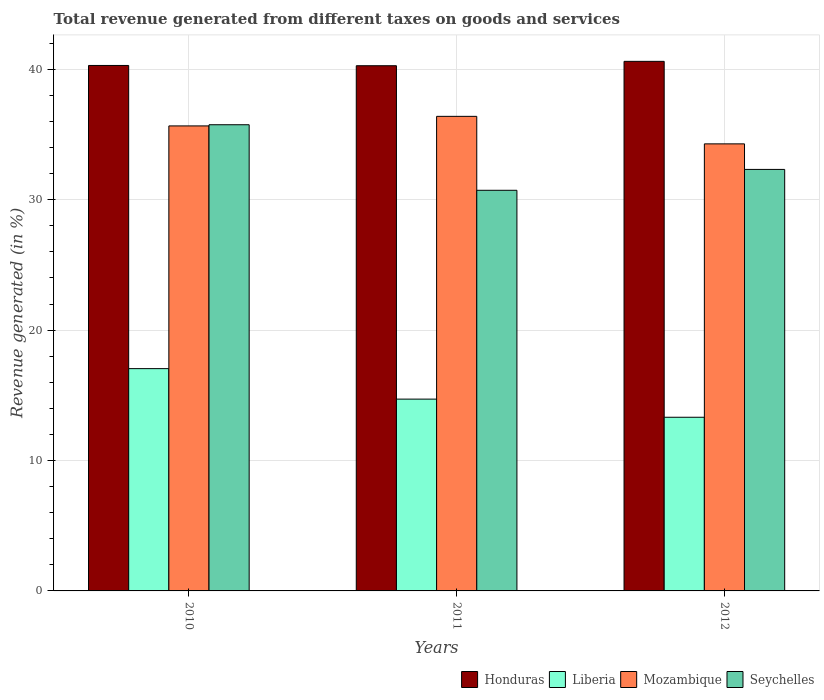How many groups of bars are there?
Your answer should be compact. 3. What is the label of the 3rd group of bars from the left?
Give a very brief answer. 2012. In how many cases, is the number of bars for a given year not equal to the number of legend labels?
Provide a short and direct response. 0. What is the total revenue generated in Mozambique in 2010?
Ensure brevity in your answer.  35.66. Across all years, what is the maximum total revenue generated in Mozambique?
Offer a very short reply. 36.39. Across all years, what is the minimum total revenue generated in Liberia?
Make the answer very short. 13.32. In which year was the total revenue generated in Seychelles minimum?
Your answer should be very brief. 2011. What is the total total revenue generated in Seychelles in the graph?
Provide a succinct answer. 98.79. What is the difference between the total revenue generated in Seychelles in 2010 and that in 2011?
Your answer should be very brief. 5.03. What is the difference between the total revenue generated in Honduras in 2010 and the total revenue generated in Liberia in 2012?
Your answer should be very brief. 26.98. What is the average total revenue generated in Honduras per year?
Provide a succinct answer. 40.39. In the year 2010, what is the difference between the total revenue generated in Honduras and total revenue generated in Mozambique?
Give a very brief answer. 4.64. What is the ratio of the total revenue generated in Liberia in 2010 to that in 2012?
Offer a very short reply. 1.28. Is the total revenue generated in Liberia in 2010 less than that in 2011?
Your answer should be very brief. No. What is the difference between the highest and the second highest total revenue generated in Honduras?
Provide a short and direct response. 0.31. What is the difference between the highest and the lowest total revenue generated in Mozambique?
Provide a succinct answer. 2.11. Is it the case that in every year, the sum of the total revenue generated in Mozambique and total revenue generated in Seychelles is greater than the sum of total revenue generated in Liberia and total revenue generated in Honduras?
Offer a terse response. No. What does the 4th bar from the left in 2010 represents?
Your response must be concise. Seychelles. What does the 2nd bar from the right in 2011 represents?
Your response must be concise. Mozambique. How many bars are there?
Keep it short and to the point. 12. Are all the bars in the graph horizontal?
Provide a succinct answer. No. How many years are there in the graph?
Make the answer very short. 3. What is the difference between two consecutive major ticks on the Y-axis?
Offer a very short reply. 10. Does the graph contain any zero values?
Give a very brief answer. No. Does the graph contain grids?
Make the answer very short. Yes. Where does the legend appear in the graph?
Make the answer very short. Bottom right. How are the legend labels stacked?
Provide a short and direct response. Horizontal. What is the title of the graph?
Provide a succinct answer. Total revenue generated from different taxes on goods and services. Does "El Salvador" appear as one of the legend labels in the graph?
Your answer should be compact. No. What is the label or title of the Y-axis?
Provide a succinct answer. Revenue generated (in %). What is the Revenue generated (in %) of Honduras in 2010?
Give a very brief answer. 40.29. What is the Revenue generated (in %) in Liberia in 2010?
Your response must be concise. 17.05. What is the Revenue generated (in %) of Mozambique in 2010?
Your response must be concise. 35.66. What is the Revenue generated (in %) in Seychelles in 2010?
Your response must be concise. 35.75. What is the Revenue generated (in %) in Honduras in 2011?
Offer a terse response. 40.27. What is the Revenue generated (in %) in Liberia in 2011?
Provide a succinct answer. 14.71. What is the Revenue generated (in %) of Mozambique in 2011?
Give a very brief answer. 36.39. What is the Revenue generated (in %) in Seychelles in 2011?
Provide a short and direct response. 30.72. What is the Revenue generated (in %) of Honduras in 2012?
Make the answer very short. 40.61. What is the Revenue generated (in %) in Liberia in 2012?
Provide a succinct answer. 13.32. What is the Revenue generated (in %) in Mozambique in 2012?
Your response must be concise. 34.28. What is the Revenue generated (in %) in Seychelles in 2012?
Your response must be concise. 32.32. Across all years, what is the maximum Revenue generated (in %) of Honduras?
Your answer should be compact. 40.61. Across all years, what is the maximum Revenue generated (in %) in Liberia?
Your answer should be very brief. 17.05. Across all years, what is the maximum Revenue generated (in %) of Mozambique?
Your response must be concise. 36.39. Across all years, what is the maximum Revenue generated (in %) of Seychelles?
Keep it short and to the point. 35.75. Across all years, what is the minimum Revenue generated (in %) of Honduras?
Offer a terse response. 40.27. Across all years, what is the minimum Revenue generated (in %) of Liberia?
Provide a succinct answer. 13.32. Across all years, what is the minimum Revenue generated (in %) of Mozambique?
Give a very brief answer. 34.28. Across all years, what is the minimum Revenue generated (in %) of Seychelles?
Ensure brevity in your answer.  30.72. What is the total Revenue generated (in %) in Honduras in the graph?
Provide a succinct answer. 121.17. What is the total Revenue generated (in %) in Liberia in the graph?
Your answer should be compact. 45.07. What is the total Revenue generated (in %) of Mozambique in the graph?
Provide a short and direct response. 106.33. What is the total Revenue generated (in %) in Seychelles in the graph?
Your answer should be compact. 98.79. What is the difference between the Revenue generated (in %) of Honduras in 2010 and that in 2011?
Make the answer very short. 0.02. What is the difference between the Revenue generated (in %) of Liberia in 2010 and that in 2011?
Provide a succinct answer. 2.34. What is the difference between the Revenue generated (in %) in Mozambique in 2010 and that in 2011?
Offer a terse response. -0.73. What is the difference between the Revenue generated (in %) of Seychelles in 2010 and that in 2011?
Offer a very short reply. 5.03. What is the difference between the Revenue generated (in %) of Honduras in 2010 and that in 2012?
Provide a short and direct response. -0.31. What is the difference between the Revenue generated (in %) in Liberia in 2010 and that in 2012?
Offer a terse response. 3.73. What is the difference between the Revenue generated (in %) of Mozambique in 2010 and that in 2012?
Ensure brevity in your answer.  1.38. What is the difference between the Revenue generated (in %) in Seychelles in 2010 and that in 2012?
Your answer should be very brief. 3.43. What is the difference between the Revenue generated (in %) in Honduras in 2011 and that in 2012?
Make the answer very short. -0.34. What is the difference between the Revenue generated (in %) of Liberia in 2011 and that in 2012?
Your answer should be very brief. 1.39. What is the difference between the Revenue generated (in %) in Mozambique in 2011 and that in 2012?
Offer a terse response. 2.11. What is the difference between the Revenue generated (in %) of Seychelles in 2011 and that in 2012?
Ensure brevity in your answer.  -1.6. What is the difference between the Revenue generated (in %) of Honduras in 2010 and the Revenue generated (in %) of Liberia in 2011?
Provide a succinct answer. 25.59. What is the difference between the Revenue generated (in %) in Honduras in 2010 and the Revenue generated (in %) in Mozambique in 2011?
Your response must be concise. 3.9. What is the difference between the Revenue generated (in %) in Honduras in 2010 and the Revenue generated (in %) in Seychelles in 2011?
Your answer should be compact. 9.57. What is the difference between the Revenue generated (in %) of Liberia in 2010 and the Revenue generated (in %) of Mozambique in 2011?
Your answer should be very brief. -19.35. What is the difference between the Revenue generated (in %) of Liberia in 2010 and the Revenue generated (in %) of Seychelles in 2011?
Your response must be concise. -13.68. What is the difference between the Revenue generated (in %) of Mozambique in 2010 and the Revenue generated (in %) of Seychelles in 2011?
Your answer should be very brief. 4.94. What is the difference between the Revenue generated (in %) of Honduras in 2010 and the Revenue generated (in %) of Liberia in 2012?
Your answer should be compact. 26.98. What is the difference between the Revenue generated (in %) of Honduras in 2010 and the Revenue generated (in %) of Mozambique in 2012?
Provide a short and direct response. 6.01. What is the difference between the Revenue generated (in %) in Honduras in 2010 and the Revenue generated (in %) in Seychelles in 2012?
Your answer should be very brief. 7.97. What is the difference between the Revenue generated (in %) of Liberia in 2010 and the Revenue generated (in %) of Mozambique in 2012?
Provide a short and direct response. -17.24. What is the difference between the Revenue generated (in %) in Liberia in 2010 and the Revenue generated (in %) in Seychelles in 2012?
Ensure brevity in your answer.  -15.28. What is the difference between the Revenue generated (in %) of Mozambique in 2010 and the Revenue generated (in %) of Seychelles in 2012?
Offer a very short reply. 3.34. What is the difference between the Revenue generated (in %) in Honduras in 2011 and the Revenue generated (in %) in Liberia in 2012?
Your answer should be compact. 26.96. What is the difference between the Revenue generated (in %) of Honduras in 2011 and the Revenue generated (in %) of Mozambique in 2012?
Offer a very short reply. 5.99. What is the difference between the Revenue generated (in %) of Honduras in 2011 and the Revenue generated (in %) of Seychelles in 2012?
Give a very brief answer. 7.95. What is the difference between the Revenue generated (in %) of Liberia in 2011 and the Revenue generated (in %) of Mozambique in 2012?
Keep it short and to the point. -19.57. What is the difference between the Revenue generated (in %) in Liberia in 2011 and the Revenue generated (in %) in Seychelles in 2012?
Ensure brevity in your answer.  -17.61. What is the difference between the Revenue generated (in %) of Mozambique in 2011 and the Revenue generated (in %) of Seychelles in 2012?
Your answer should be compact. 4.07. What is the average Revenue generated (in %) in Honduras per year?
Your answer should be very brief. 40.39. What is the average Revenue generated (in %) in Liberia per year?
Ensure brevity in your answer.  15.02. What is the average Revenue generated (in %) in Mozambique per year?
Provide a short and direct response. 35.44. What is the average Revenue generated (in %) in Seychelles per year?
Give a very brief answer. 32.93. In the year 2010, what is the difference between the Revenue generated (in %) in Honduras and Revenue generated (in %) in Liberia?
Offer a very short reply. 23.25. In the year 2010, what is the difference between the Revenue generated (in %) of Honduras and Revenue generated (in %) of Mozambique?
Give a very brief answer. 4.64. In the year 2010, what is the difference between the Revenue generated (in %) in Honduras and Revenue generated (in %) in Seychelles?
Offer a very short reply. 4.55. In the year 2010, what is the difference between the Revenue generated (in %) of Liberia and Revenue generated (in %) of Mozambique?
Keep it short and to the point. -18.61. In the year 2010, what is the difference between the Revenue generated (in %) of Liberia and Revenue generated (in %) of Seychelles?
Ensure brevity in your answer.  -18.7. In the year 2010, what is the difference between the Revenue generated (in %) of Mozambique and Revenue generated (in %) of Seychelles?
Offer a very short reply. -0.09. In the year 2011, what is the difference between the Revenue generated (in %) of Honduras and Revenue generated (in %) of Liberia?
Provide a succinct answer. 25.56. In the year 2011, what is the difference between the Revenue generated (in %) in Honduras and Revenue generated (in %) in Mozambique?
Make the answer very short. 3.88. In the year 2011, what is the difference between the Revenue generated (in %) in Honduras and Revenue generated (in %) in Seychelles?
Your answer should be very brief. 9.55. In the year 2011, what is the difference between the Revenue generated (in %) of Liberia and Revenue generated (in %) of Mozambique?
Provide a short and direct response. -21.68. In the year 2011, what is the difference between the Revenue generated (in %) of Liberia and Revenue generated (in %) of Seychelles?
Keep it short and to the point. -16.01. In the year 2011, what is the difference between the Revenue generated (in %) in Mozambique and Revenue generated (in %) in Seychelles?
Make the answer very short. 5.67. In the year 2012, what is the difference between the Revenue generated (in %) of Honduras and Revenue generated (in %) of Liberia?
Provide a short and direct response. 27.29. In the year 2012, what is the difference between the Revenue generated (in %) of Honduras and Revenue generated (in %) of Mozambique?
Your response must be concise. 6.33. In the year 2012, what is the difference between the Revenue generated (in %) of Honduras and Revenue generated (in %) of Seychelles?
Your answer should be very brief. 8.29. In the year 2012, what is the difference between the Revenue generated (in %) in Liberia and Revenue generated (in %) in Mozambique?
Provide a succinct answer. -20.96. In the year 2012, what is the difference between the Revenue generated (in %) of Liberia and Revenue generated (in %) of Seychelles?
Provide a short and direct response. -19.01. In the year 2012, what is the difference between the Revenue generated (in %) of Mozambique and Revenue generated (in %) of Seychelles?
Provide a succinct answer. 1.96. What is the ratio of the Revenue generated (in %) in Honduras in 2010 to that in 2011?
Your answer should be very brief. 1. What is the ratio of the Revenue generated (in %) in Liberia in 2010 to that in 2011?
Offer a very short reply. 1.16. What is the ratio of the Revenue generated (in %) of Mozambique in 2010 to that in 2011?
Give a very brief answer. 0.98. What is the ratio of the Revenue generated (in %) in Seychelles in 2010 to that in 2011?
Provide a succinct answer. 1.16. What is the ratio of the Revenue generated (in %) in Honduras in 2010 to that in 2012?
Your answer should be compact. 0.99. What is the ratio of the Revenue generated (in %) of Liberia in 2010 to that in 2012?
Make the answer very short. 1.28. What is the ratio of the Revenue generated (in %) of Mozambique in 2010 to that in 2012?
Your response must be concise. 1.04. What is the ratio of the Revenue generated (in %) in Seychelles in 2010 to that in 2012?
Provide a short and direct response. 1.11. What is the ratio of the Revenue generated (in %) in Liberia in 2011 to that in 2012?
Give a very brief answer. 1.1. What is the ratio of the Revenue generated (in %) of Mozambique in 2011 to that in 2012?
Your answer should be compact. 1.06. What is the ratio of the Revenue generated (in %) of Seychelles in 2011 to that in 2012?
Provide a succinct answer. 0.95. What is the difference between the highest and the second highest Revenue generated (in %) in Honduras?
Give a very brief answer. 0.31. What is the difference between the highest and the second highest Revenue generated (in %) in Liberia?
Offer a very short reply. 2.34. What is the difference between the highest and the second highest Revenue generated (in %) in Mozambique?
Offer a terse response. 0.73. What is the difference between the highest and the second highest Revenue generated (in %) of Seychelles?
Provide a succinct answer. 3.43. What is the difference between the highest and the lowest Revenue generated (in %) of Honduras?
Make the answer very short. 0.34. What is the difference between the highest and the lowest Revenue generated (in %) in Liberia?
Your answer should be compact. 3.73. What is the difference between the highest and the lowest Revenue generated (in %) in Mozambique?
Provide a succinct answer. 2.11. What is the difference between the highest and the lowest Revenue generated (in %) of Seychelles?
Provide a short and direct response. 5.03. 